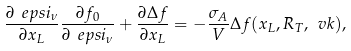<formula> <loc_0><loc_0><loc_500><loc_500>\frac { \partial \ e p s i _ { \nu } } { \partial x _ { L } } \frac { \partial f _ { 0 } } { \partial \ e p s i _ { \nu } } + \frac { \partial \Delta f } { \partial x _ { L } } = - \frac { \sigma _ { A } } { V } \Delta f ( x _ { L } , R _ { T } , \ v k ) ,</formula> 